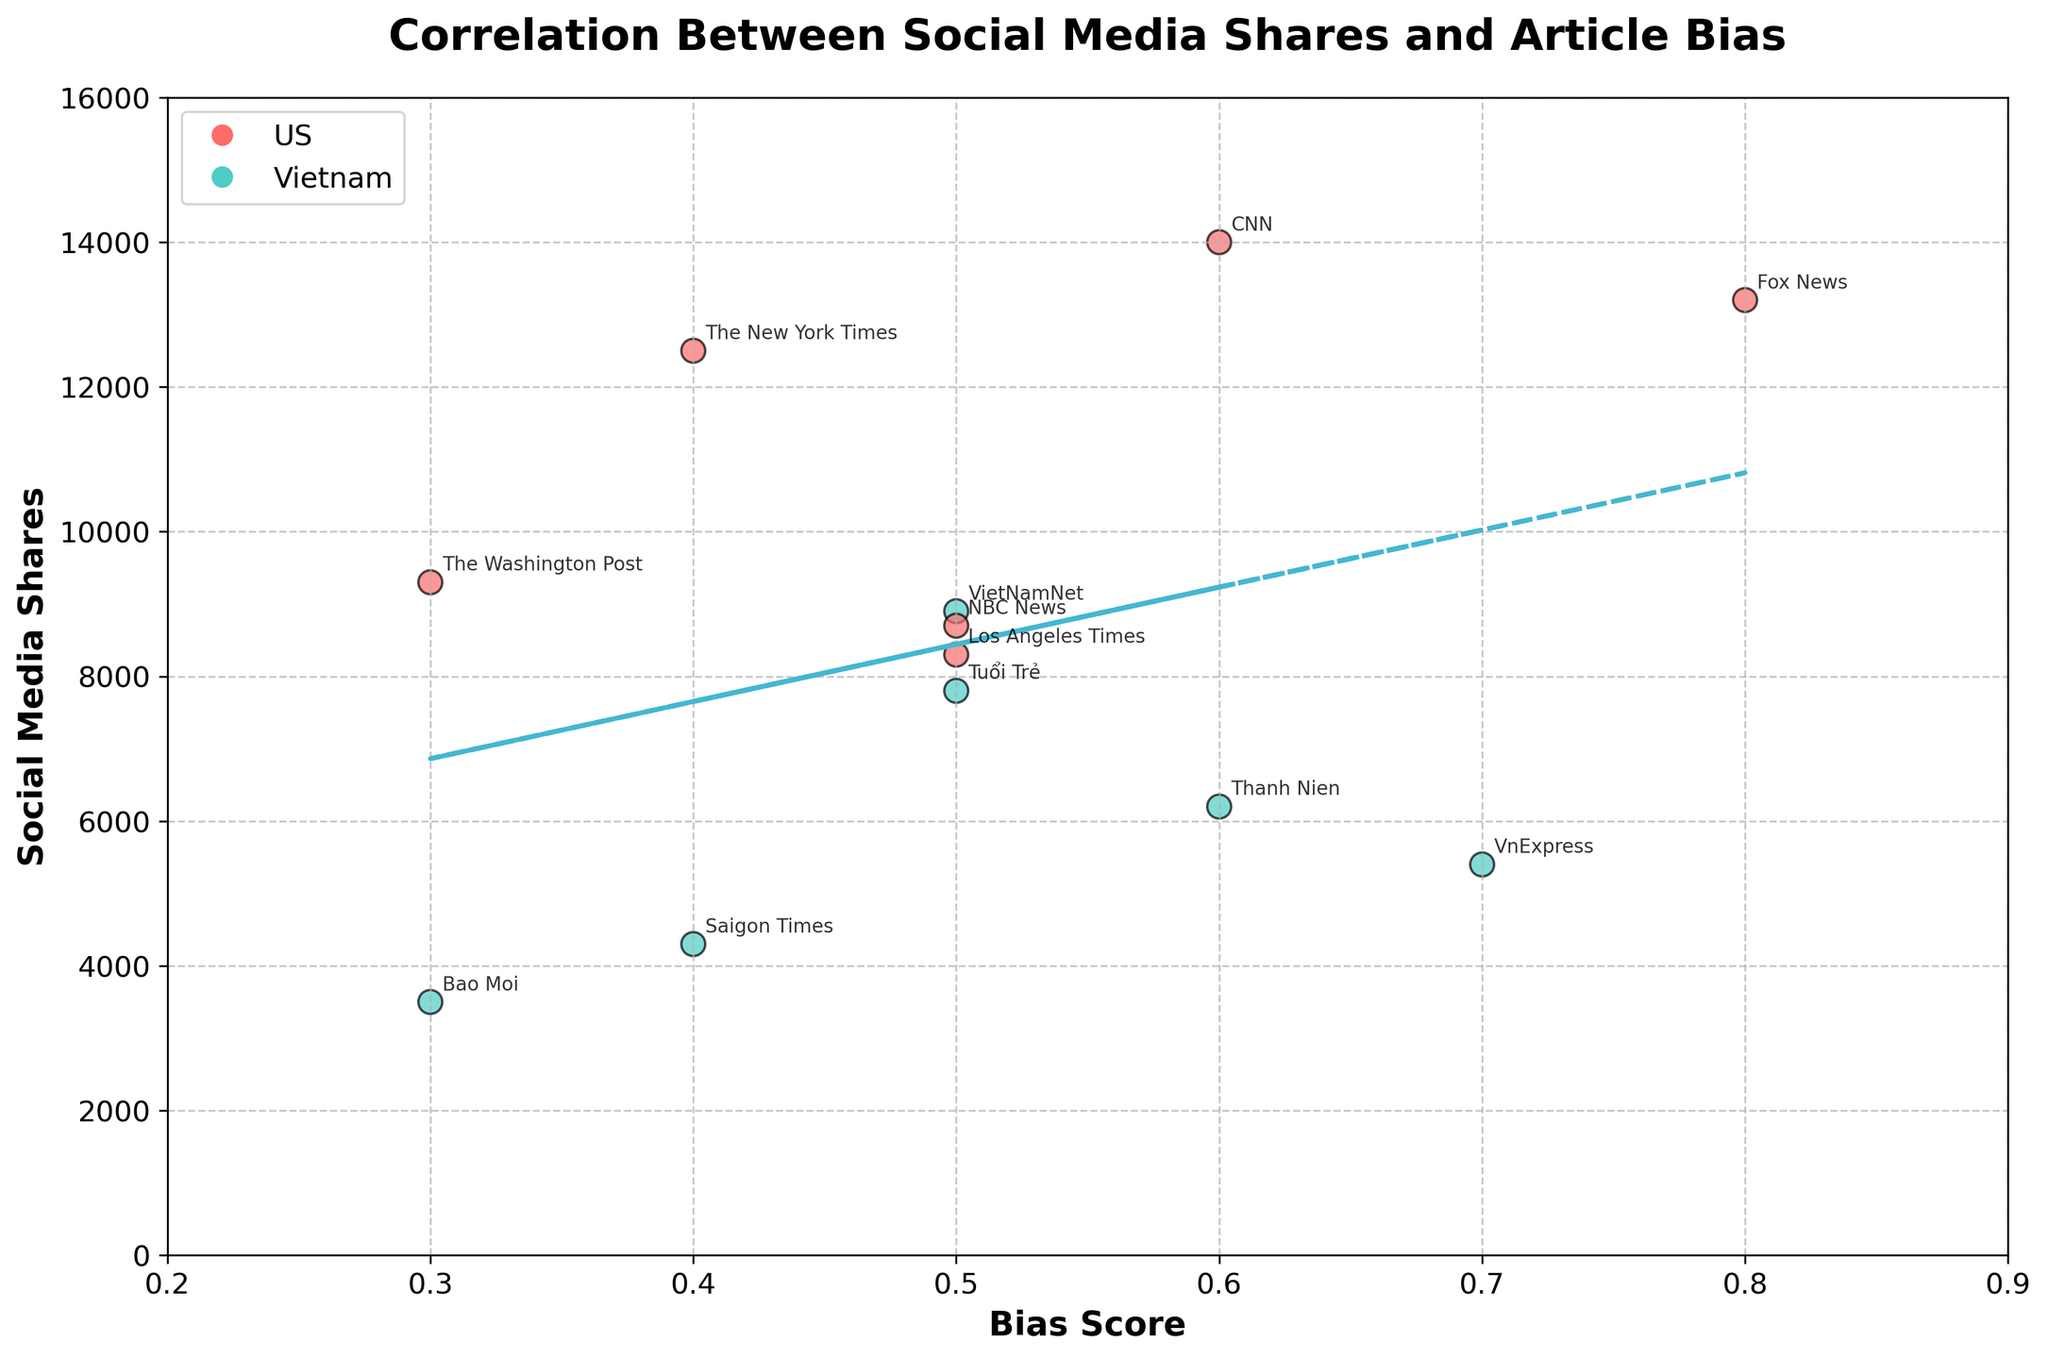How many data points are included in the scatter plot? By inspecting the scatter plot, count the number of unique points plotted on the graph, each representing an article from a different outlet.
Answer: 12 What colors are used to differentiate between US and Vietnamese news outlets? The scatter plot uses two distinct colors: one color for US outlets and another for Vietnamese outlets.
Answer: Red for US, Green for Vietnam Which outlet has the highest number of social media shares and what's its bias score? Identify the data point that peaks in social media shares and note its corresponding outlet and bias score. This point is the highest one on the y-axis.
Answer: CNN, 0.6 What is the overall trend shown by the trend line? Examine the trend line to understand the relationship it depicts between the bias score and social media shares. Determine whether it shows an increase, decrease, or no change.
Answer: Slight positive correlation Which Vietnamese outlet has the highest bias score, and how many social media shares does it have? Look for the Vietnamese data point with the highest value on the x-axis (bias score) and note its corresponding social media shares.
Answer: VnExpress, 5400 How does the bias score of "The New York Times" compare to "Fox News"? Locate both data points on the plot and compare their x-axis values to understand which has a higher bias score.
Answer: Fox News has a higher bias score What's the average bias score of US news outlets shown in the plot? Sum up the bias scores of all US outlets and divide by the number of US outlets (6).
Answer: 0.5167 How many US outlets have a social media share count higher than 10,000? Identify the US data points on the plot that have y-values greater than 10,000 and count them.
Answer: 2 Which data point has the lowest social media share count, and what is its bias score? Find the data point that is lowest on the y-axis and note its corresponding bias score.
Answer: Bao Moi, 0.3 Are there more US or Vietnamese outlets with a bias score of at least 0.5? Count the number of data points for each country that have an x-value (bias score) of 0.5 or higher.
Answer: Vietnamese outlets 